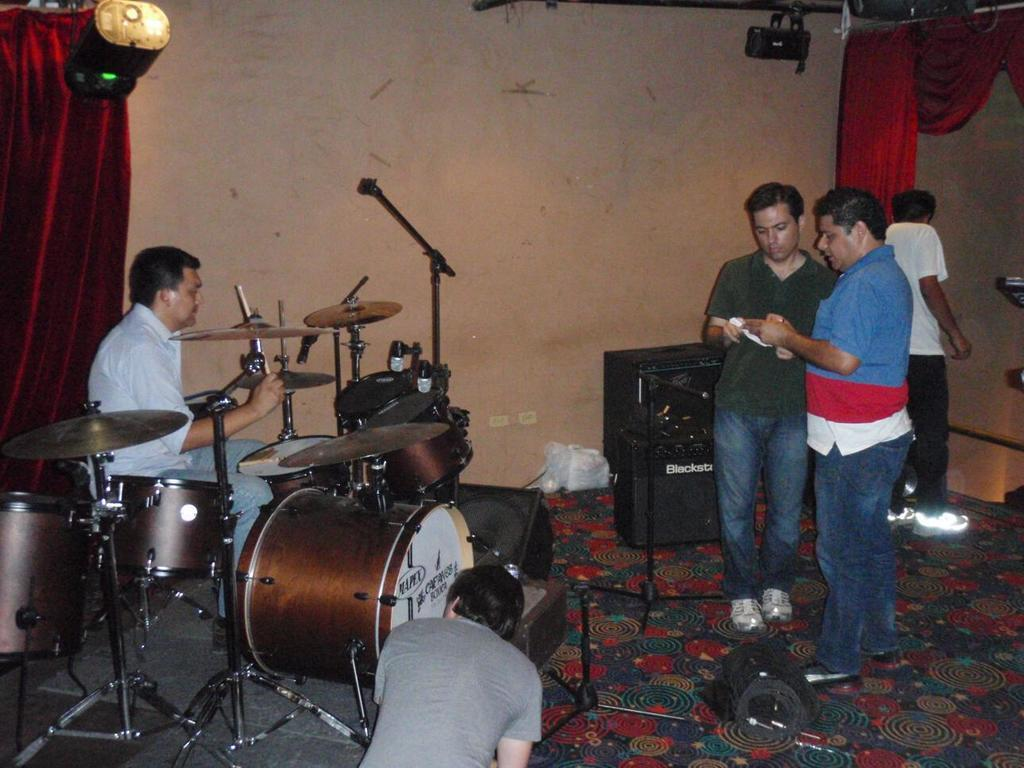What is the main activity being performed in the image? There is a person playing electronic drums in the image. Are there any other people present in the image? Yes, there are people standing in the image. What can be seen in the background of the image? There is a curtain, a speaker, a wall, and show lights in the background of the image. What is the mom's reaction to the fear in the hall in the image? There is no mention of a mom, fear, or hall in the image. The image features a person playing electronic drums and other people standing nearby, with various background elements. 